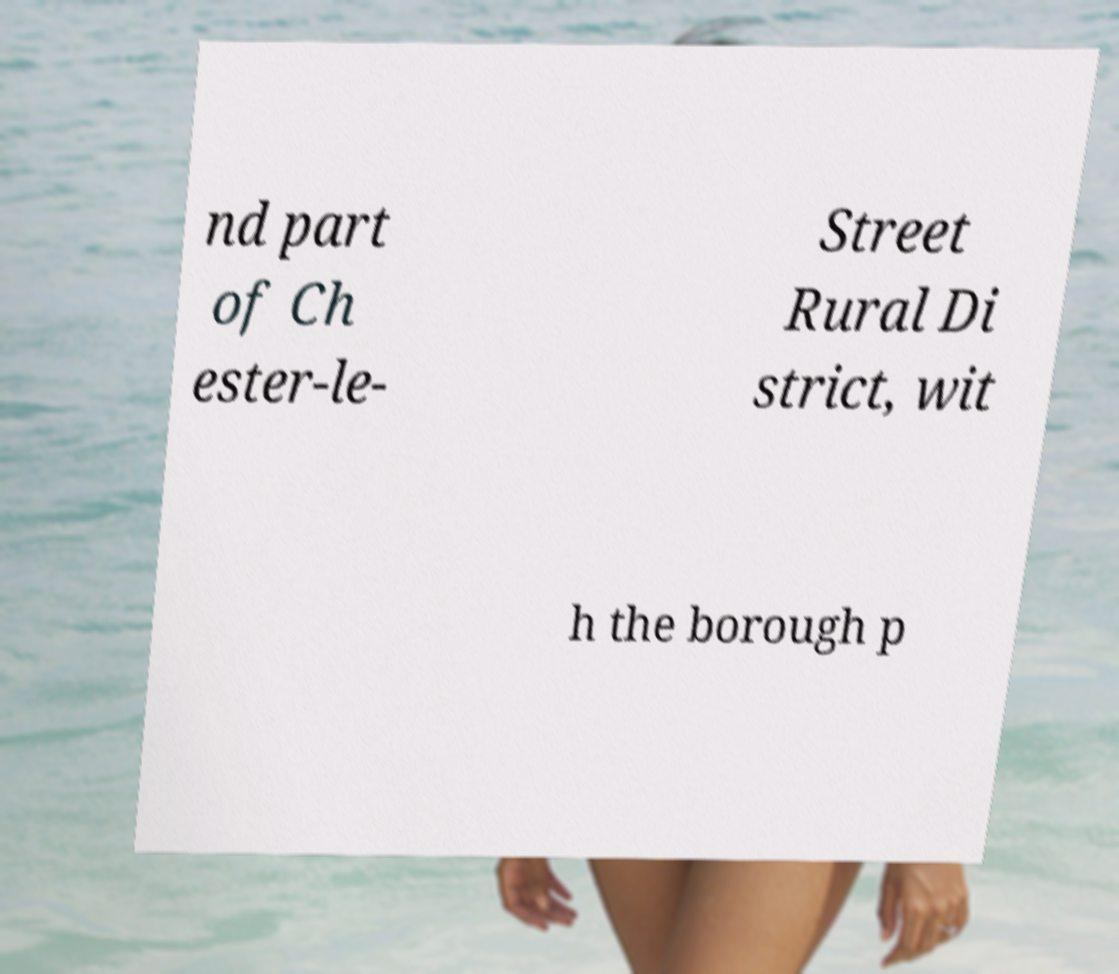I need the written content from this picture converted into text. Can you do that? nd part of Ch ester-le- Street Rural Di strict, wit h the borough p 